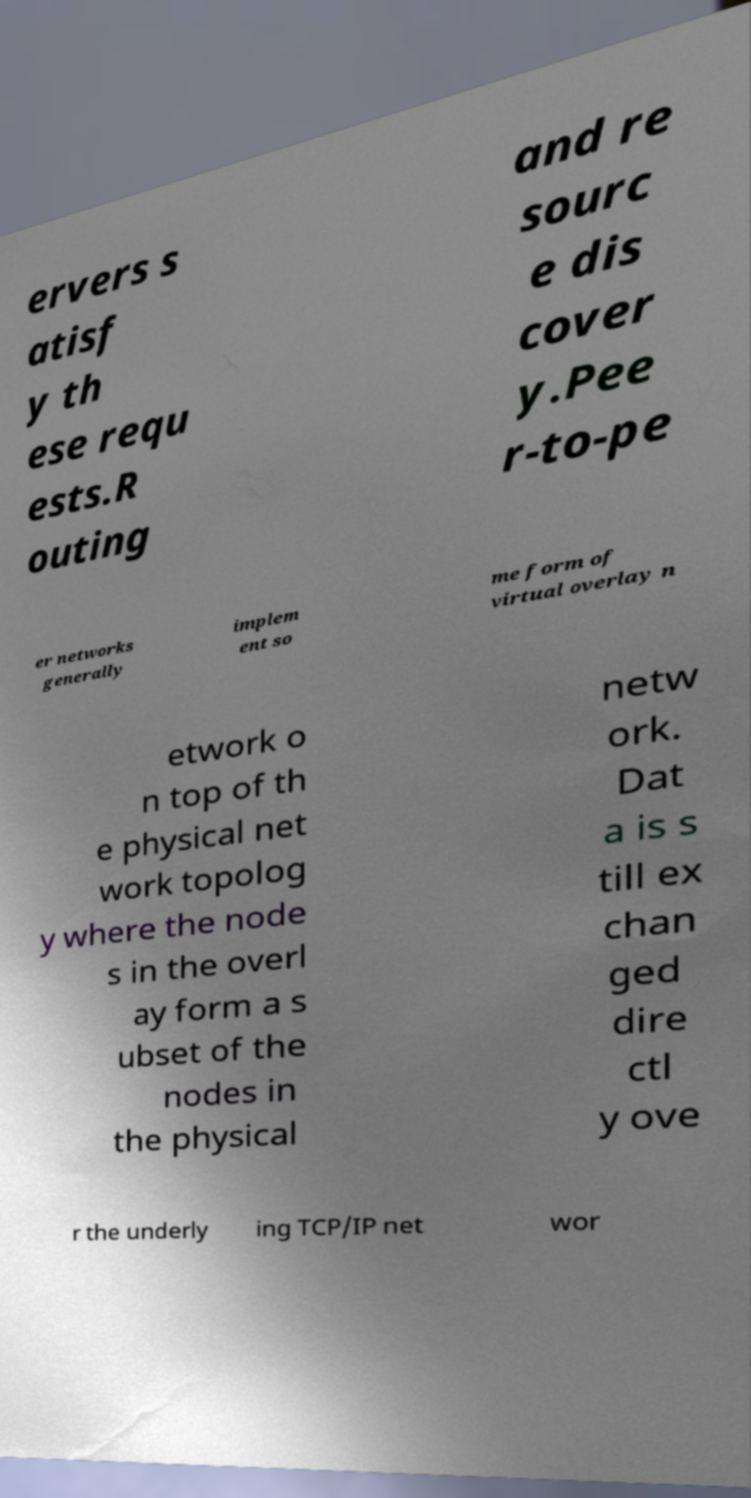For documentation purposes, I need the text within this image transcribed. Could you provide that? ervers s atisf y th ese requ ests.R outing and re sourc e dis cover y.Pee r-to-pe er networks generally implem ent so me form of virtual overlay n etwork o n top of th e physical net work topolog y where the node s in the overl ay form a s ubset of the nodes in the physical netw ork. Dat a is s till ex chan ged dire ctl y ove r the underly ing TCP/IP net wor 